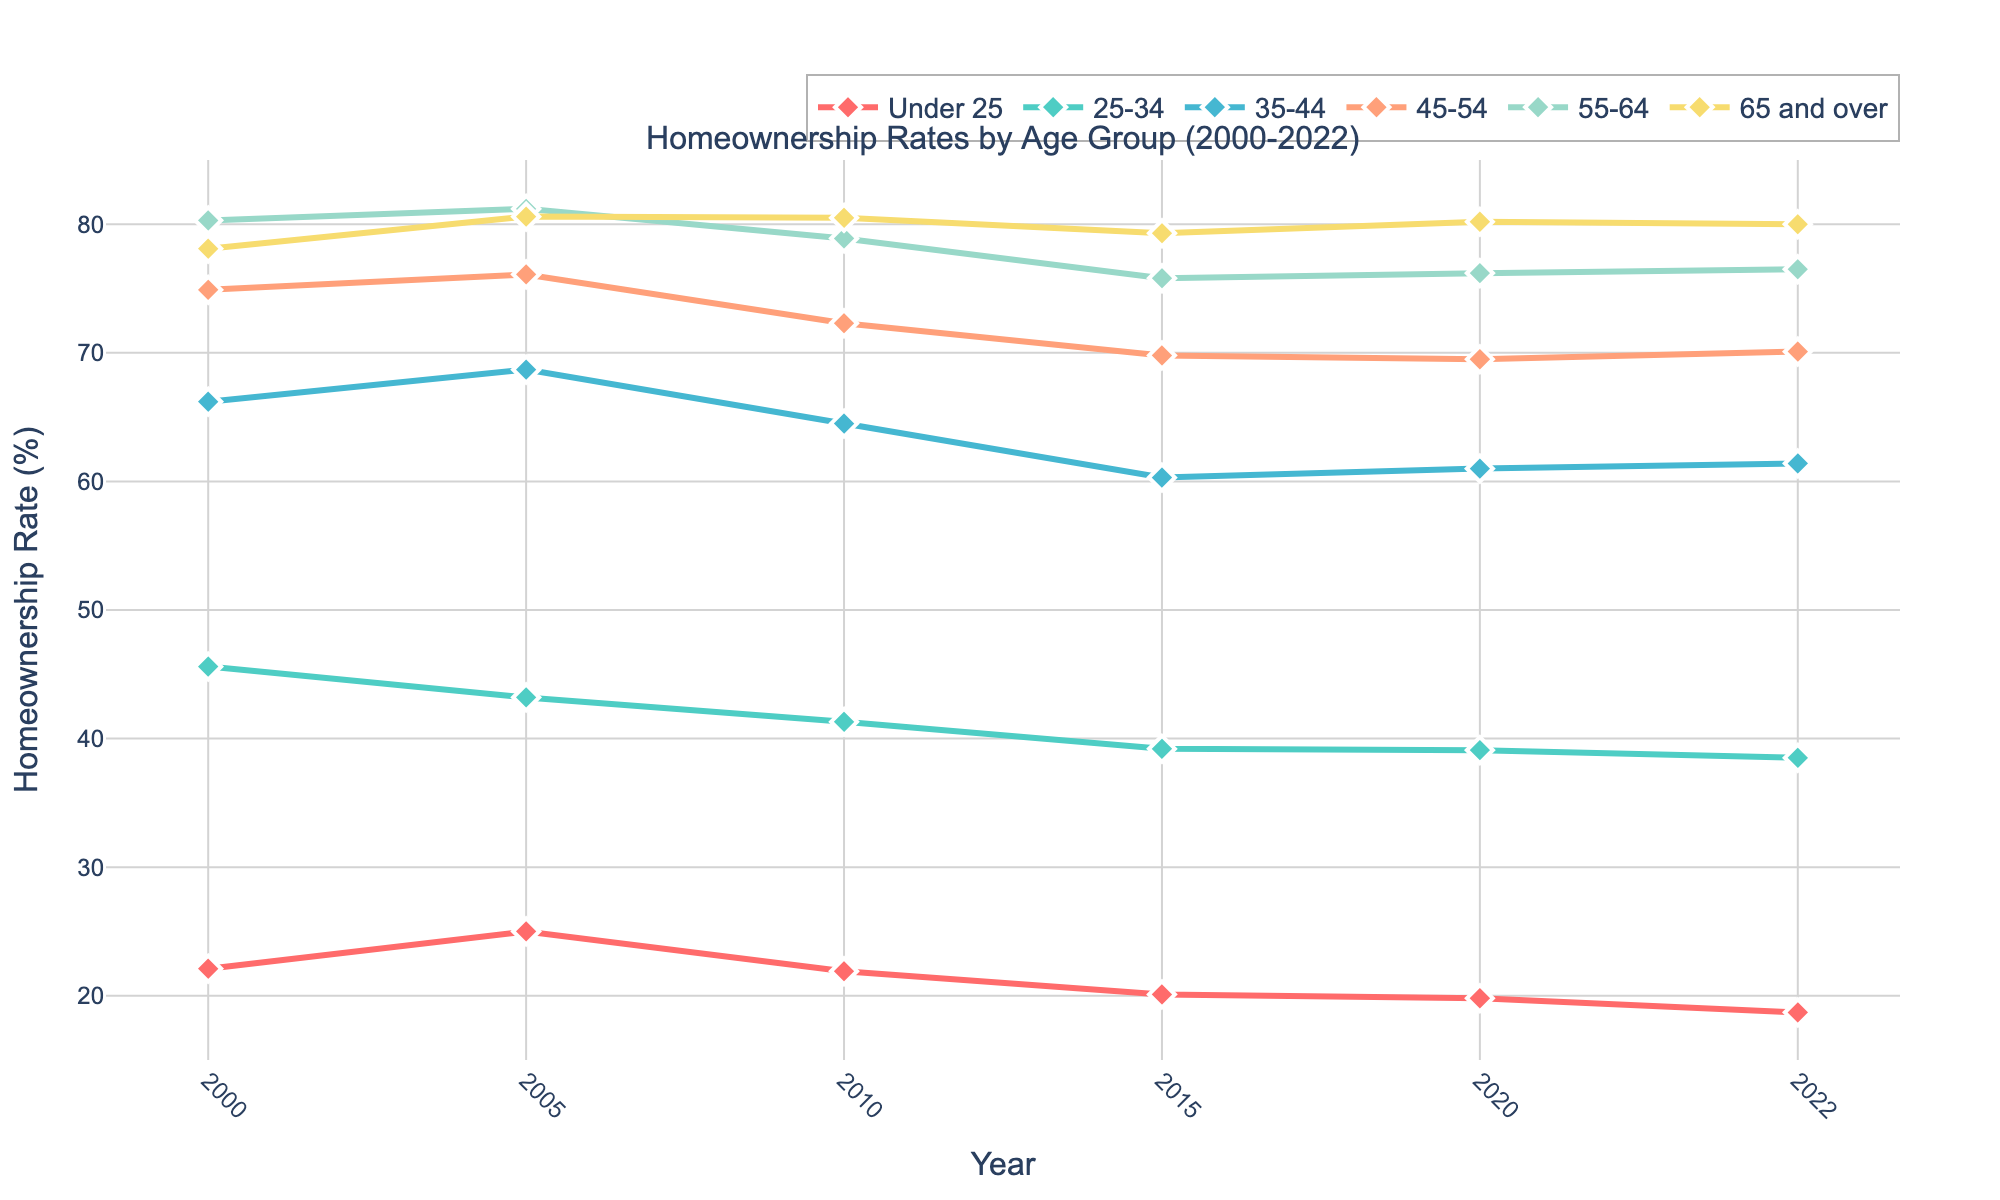What is the homeownership rate for the 35-44 age group in 2020? Identify the line corresponding to the 35-44 age group and locate the data point for the year 2020.
Answer: 61.0% Between which age groups does the largest difference in homeownership rates appear in 2022? Compare the homeownership rates of all age groups in 2022 to find the largest difference. The largest gap appears between the 65 and over group and the Under 25 group.
Answer: 65 and over and Under 25 Which age group experienced a continuous decline in homeownership rates from 2000 to 2022? Follow the trend lines of each age group from 2000 to 2022 to identify the one that shows a consistent decrease. The Under 25 group shows a continuous decline.
Answer: Under 25 What is the average homeownership rate for the 55-64 age group over the years provided? Add the homeownership rates of the 55-64 age group for each year and divide by the number of years to find the average. (80.3 + 81.2 + 78.9 + 75.8 + 76.2 + 76.5) / 6 = 78.15
Answer: 78.15% How does the homeownership rate of the 25-34 age group in 2022 compare to that in 2000? Find the homeownership rates for the 25-34 age group in 2000 and 2022 and compare them. The rate decreased from 45.6% in 2000 to 38.5% in 2022.
Answer: Decreased Which year shows the highest homeownership rate for the 65 and over age group? Check the homeownership rates for the 65 and over age group across all years and identify the highest one, which occurred in 2005 at 80.6%.
Answer: 2005 What is the difference in the homeownership rate between the 45-54 and the 35-44 age groups in 2015? Subtract the homeownership rate of the 35-44 age group from that of the 45-54 age group for the year 2015. 69.8% - 60.3% = 9.5%
Answer: 9.5% Which age groups saw an increase in homeownership rates from 2010 to 2022? Track the homeownership rates from 2010 to 2022 for each age group and identify those with an upward trend. The 35-44 and 45-54 age groups show an increase.
Answer: 35-44 and 45-54 